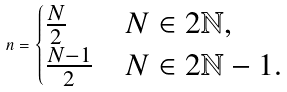<formula> <loc_0><loc_0><loc_500><loc_500>n = \begin{cases} \frac { N } { 2 } & N \in 2 \mathbb { N } , \\ \frac { N - 1 } { 2 } & N \in 2 \mathbb { N } - 1 . \\ \end{cases}</formula> 